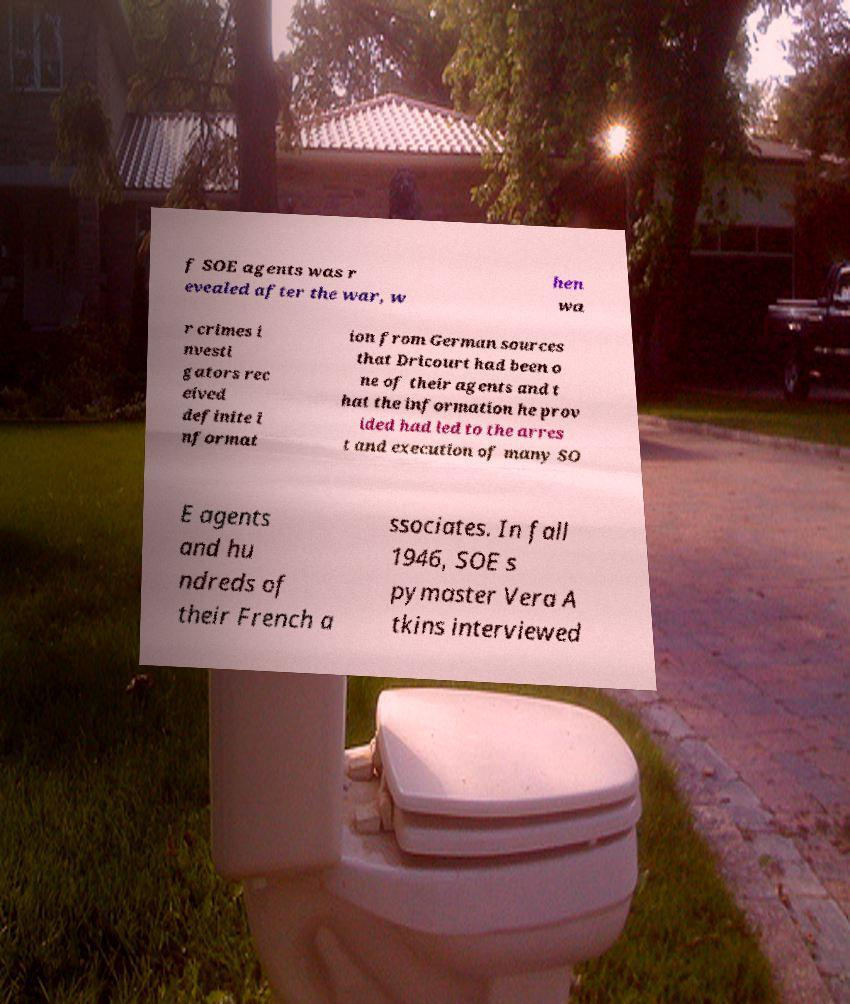Could you extract and type out the text from this image? f SOE agents was r evealed after the war, w hen wa r crimes i nvesti gators rec eived definite i nformat ion from German sources that Dricourt had been o ne of their agents and t hat the information he prov ided had led to the arres t and execution of many SO E agents and hu ndreds of their French a ssociates. In fall 1946, SOE s pymaster Vera A tkins interviewed 